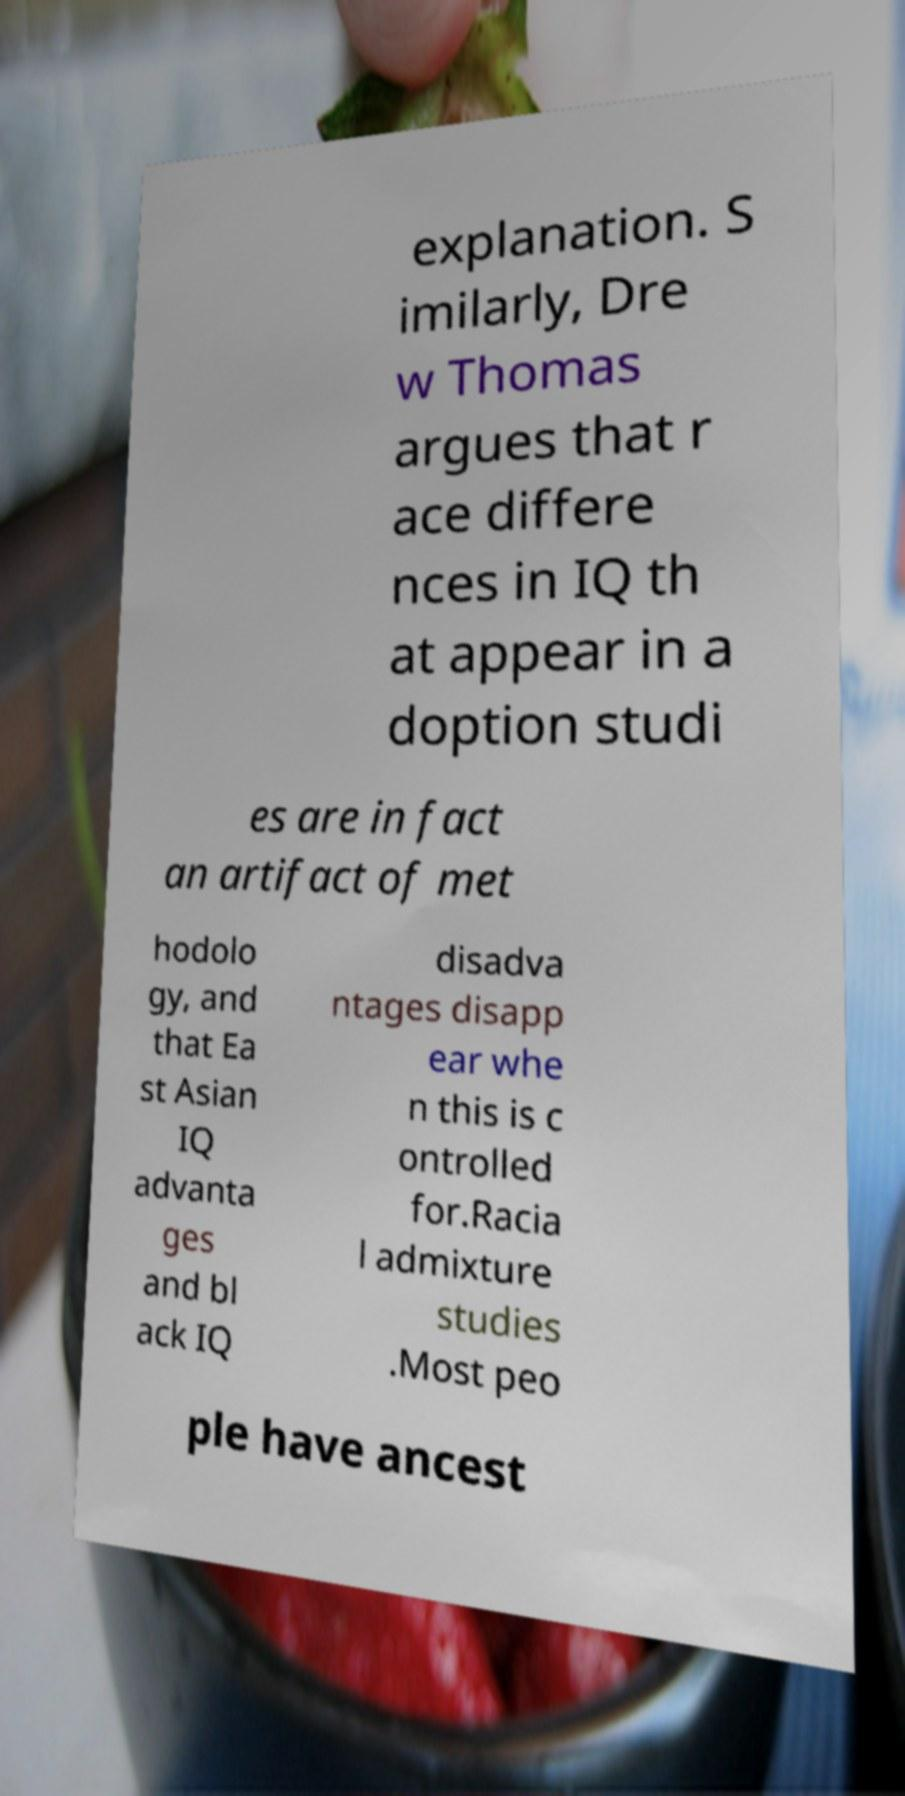For documentation purposes, I need the text within this image transcribed. Could you provide that? explanation. S imilarly, Dre w Thomas argues that r ace differe nces in IQ th at appear in a doption studi es are in fact an artifact of met hodolo gy, and that Ea st Asian IQ advanta ges and bl ack IQ disadva ntages disapp ear whe n this is c ontrolled for.Racia l admixture studies .Most peo ple have ancest 